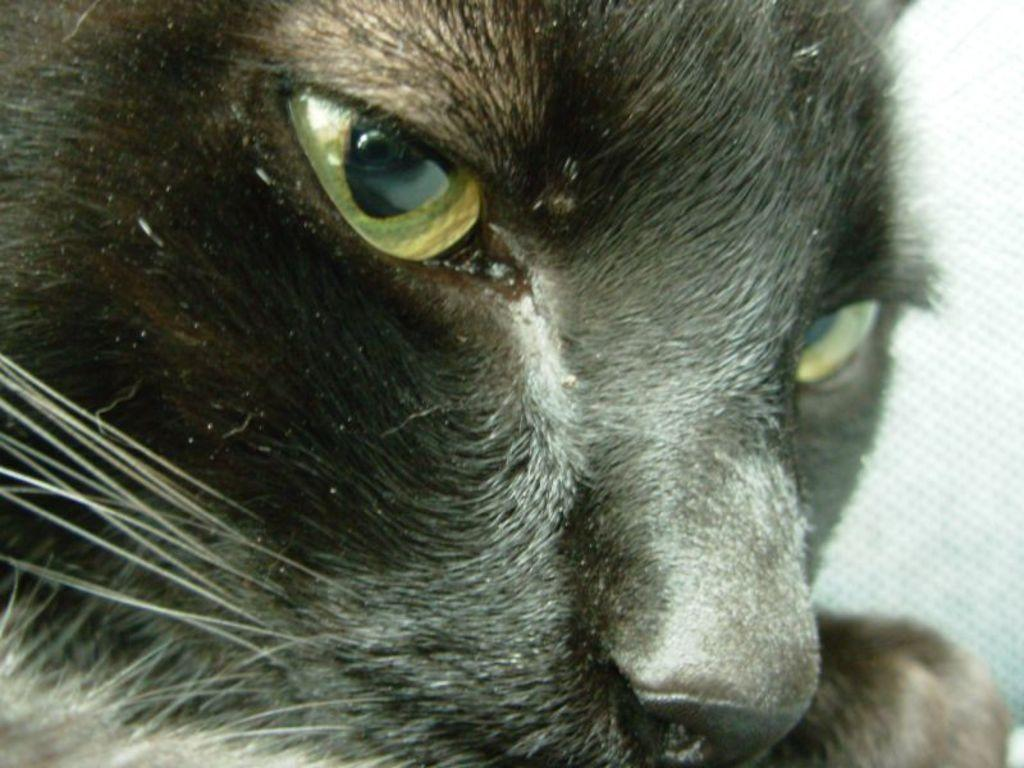What type of animal is in the image? There is a cat in the image. What color is the cat? The cat is black in color. What type of cable is the cat using to communicate with its friends on Earth? There is no cable or communication with friends on Earth depicted in the image; it simply shows a black cat. 